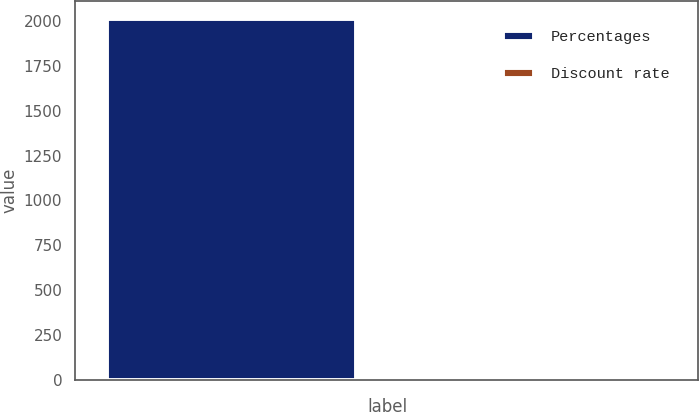Convert chart. <chart><loc_0><loc_0><loc_500><loc_500><bar_chart><fcel>Percentages<fcel>Discount rate<nl><fcel>2011<fcel>5.01<nl></chart> 